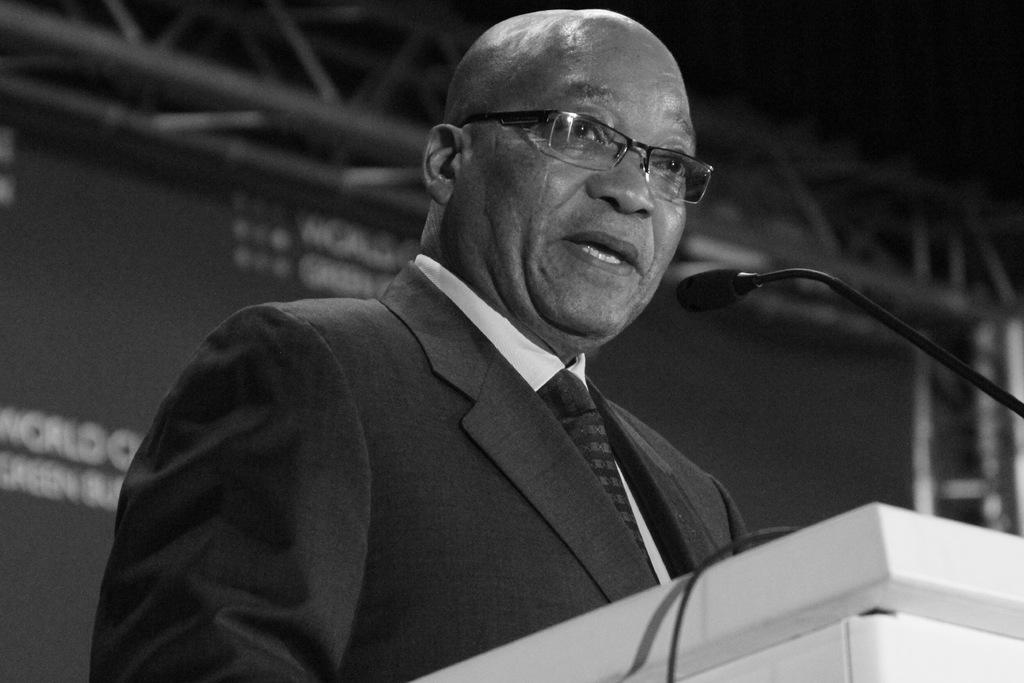What is the color scheme of the image? The image is black and white. What can be seen near the man in the image? There is a podium and a microphone in front of the man. What is present in the background of the image? There is a banner in the background. Can you see any clovers growing near the man in the image? There are no clovers visible in the image. What type of hammer is the man holding in the image? The man is not holding a hammer in the image; he is standing near a podium with a microphone in front of him. 